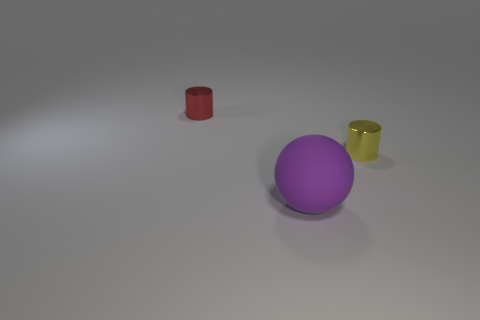Can you speculate on the material and texture of the objects? Judging by their appearance, the purple sphere seems to have a matte finish, which might indicate a surface texture of rubber or plastic. The red and yellow cylinders appear to have a shinier surface, hinting at a metallic material, possibly painted steels with a polished finish that reflects the ambient light. 